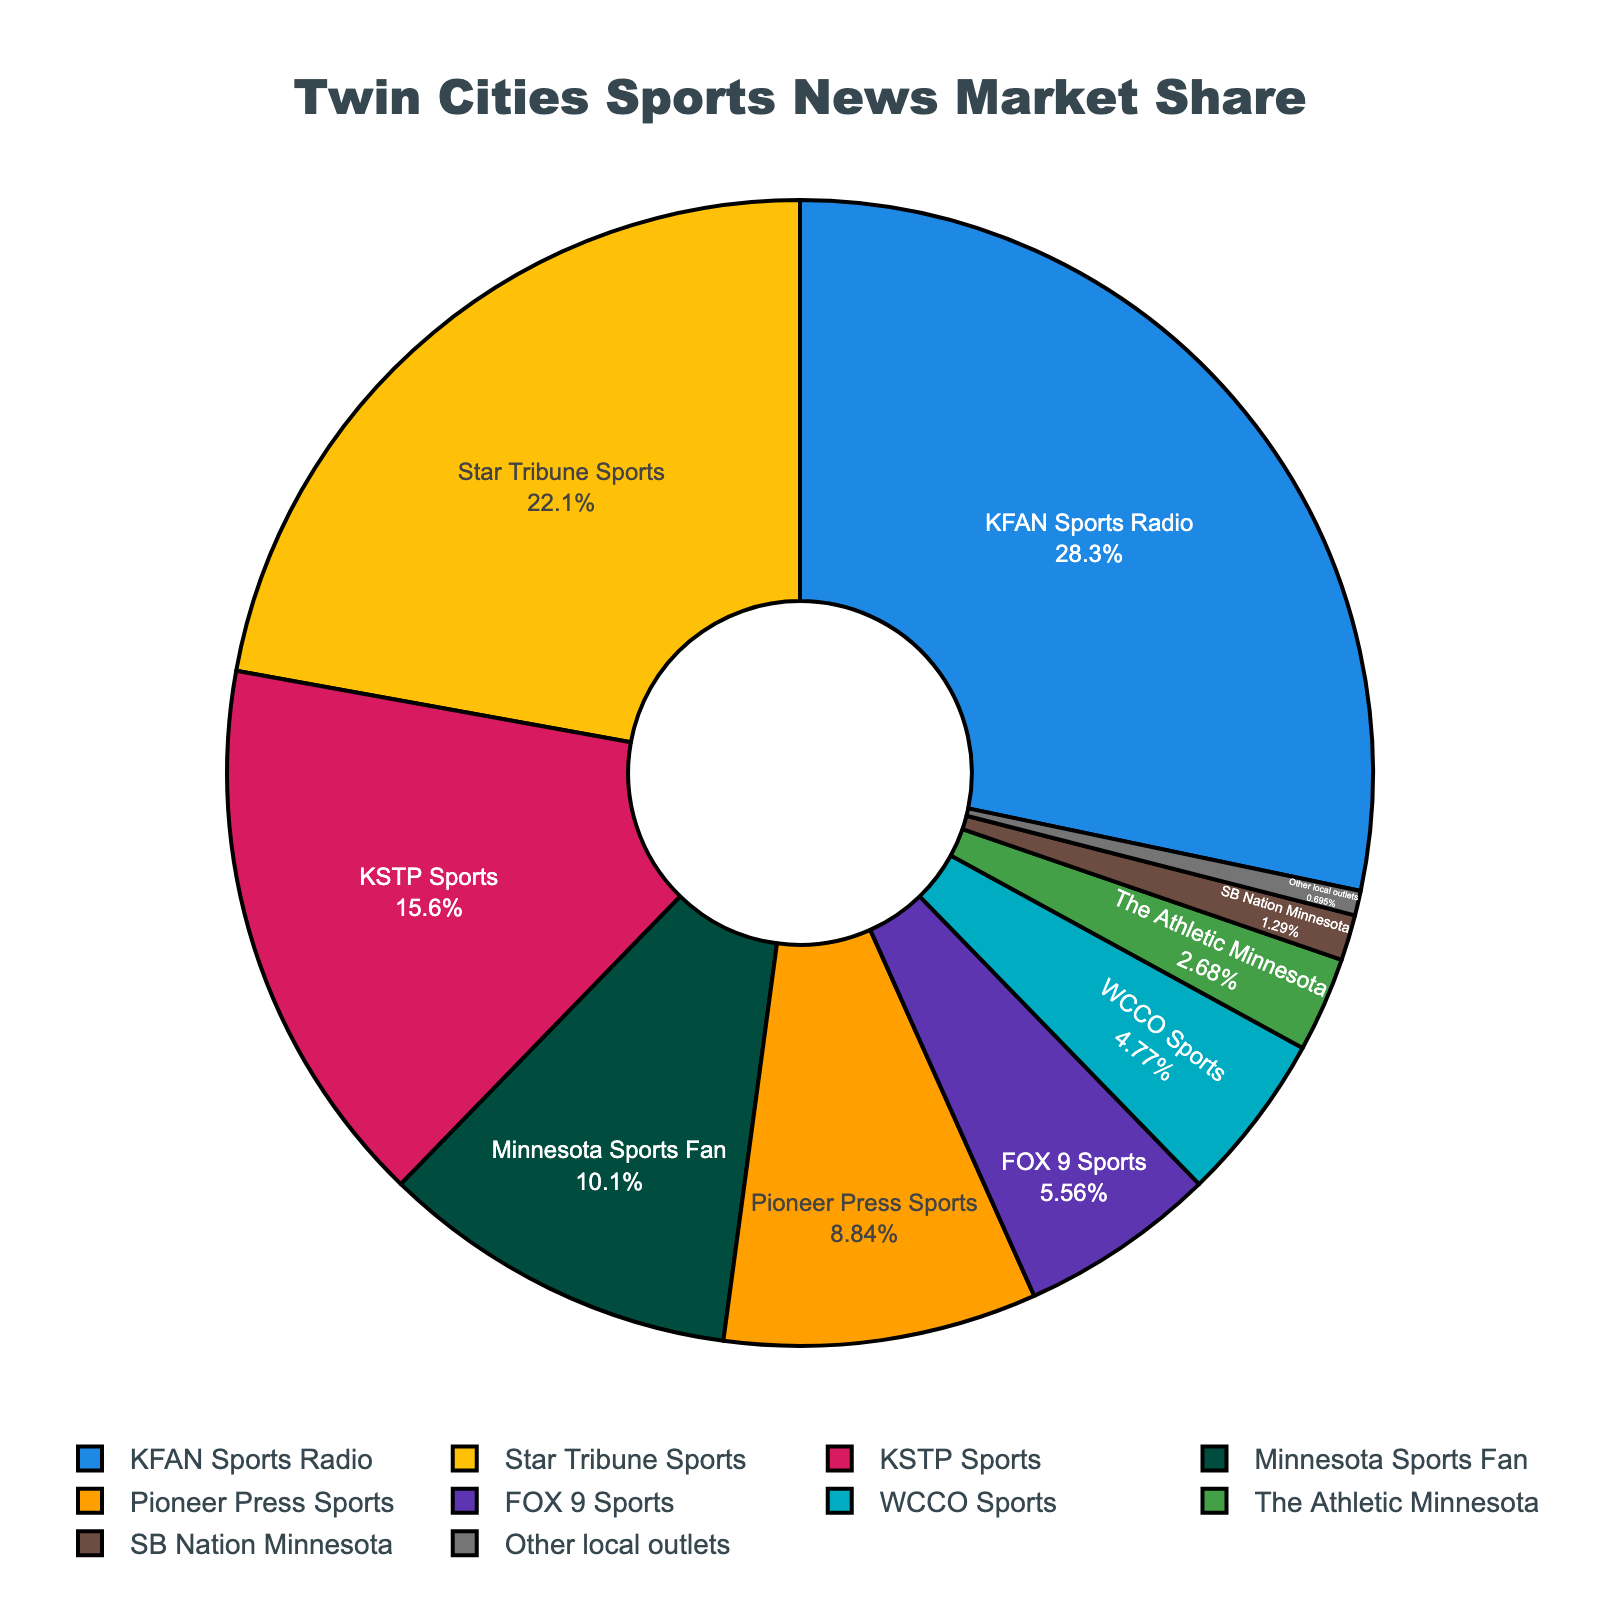what is the market share of KFAN Sports Radio? The chart shows each outlet and its respective market share percentage. KFAN Sports Radio occupies the largest segment which is labeled 28.5%.
Answer: 28.5% which outlet has the second-largest market share? By examining the pie chart segments and their corresponding labels, Star Tribune Sports has the second largest segment with 22.3%.
Answer: Star Tribune Sports what is the combined market share of Minnesota Sports Fan and Pioneer Press Sports? Add the market share percentages of Minnesota Sports Fan (10.2%) and Pioneer Press Sports (8.9%). The sum is 10.2% + 8.9% = 19.1%.
Answer: 19.1% how much greater is KFAN Sports Radio's share compared to KSTP Sports? Calculate the difference in market share between KFAN Sports Radio (28.5%) and KSTP Sports (15.7%). The result is 28.5% - 15.7% = 12.8%.
Answer: 12.8% which outlets have a market share below 5%? From the pie chart, WCCO Sports, The Athletic Minnesota, SB Nation Minnesota, and Other local outlets have market shares of 4.8%, 2.7%, 1.3%, and 0.7% respectively, all of which are less than 5%.
Answer: WCCO Sports, The Athletic Minnesota, SB Nation Minnesota, Other local outlets consider FOX 9 Sports and WCCO Sports, which one has a smaller market share and by how much? Compare the market shares of FOX 9 Sports (5.6%) and WCCO Sports (4.8%). The difference is 5.6% - 4.8% = 0.8%.
Answer: WCCO Sports by 0.8% what is the average market share of the three smallest outlets? Find the average of the market shares of Other local outlets (0.7%), SB Nation Minnesota (1.3%), and The Athletic Minnesota (2.7%). Average = (0.7% + 1.3% + 2.7%) / 3 ≈ 1.57%.
Answer: 1.57% describe the color associated with Star Tribune Sports in the chart. The pie chart uses different colors for each outlet segment. The color associated with Star Tribune Sports is yellow.
Answer: yellow which outlet has a marginally higher market share compared to WCCO Sports? The market share of WCCO Sports is 4.8%. Comparing nearby values, FOX 9 Sports has a marginally higher market share at 5.6%.
Answer: FOX 9 Sports by how much do the top three outlets (KFAN Sports Radio, Star Tribune Sports, and KSTP Sports) dominate the market share combined? Sum the market shares of KFAN Sports Radio (28.5%), Star Tribune Sports (22.3%), and KSTP Sports (15.7%). Combined market share = 28.5% + 22.3% + 15.7% = 66.5%.
Answer: 66.5% 